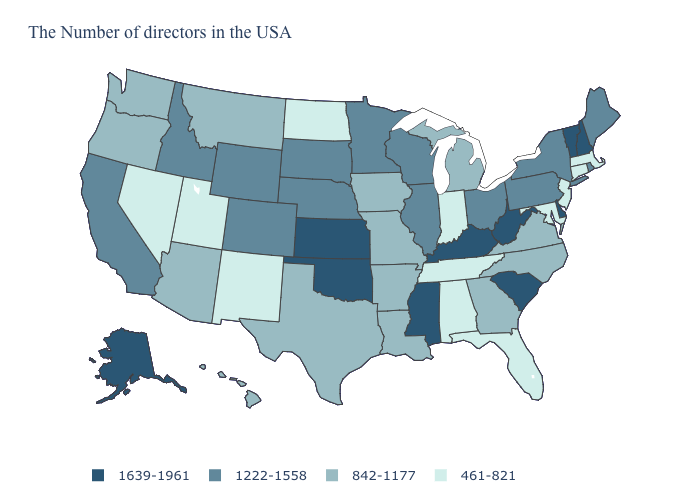Does Vermont have the same value as Nebraska?
Concise answer only. No. Name the states that have a value in the range 842-1177?
Concise answer only. Virginia, North Carolina, Georgia, Michigan, Louisiana, Missouri, Arkansas, Iowa, Texas, Montana, Arizona, Washington, Oregon, Hawaii. Does the map have missing data?
Be succinct. No. Name the states that have a value in the range 842-1177?
Give a very brief answer. Virginia, North Carolina, Georgia, Michigan, Louisiana, Missouri, Arkansas, Iowa, Texas, Montana, Arizona, Washington, Oregon, Hawaii. Is the legend a continuous bar?
Be succinct. No. Does Tennessee have a lower value than South Carolina?
Short answer required. Yes. Does the map have missing data?
Give a very brief answer. No. Name the states that have a value in the range 842-1177?
Give a very brief answer. Virginia, North Carolina, Georgia, Michigan, Louisiana, Missouri, Arkansas, Iowa, Texas, Montana, Arizona, Washington, Oregon, Hawaii. Does the map have missing data?
Concise answer only. No. Among the states that border Arkansas , which have the highest value?
Concise answer only. Mississippi, Oklahoma. What is the value of Minnesota?
Be succinct. 1222-1558. How many symbols are there in the legend?
Write a very short answer. 4. Name the states that have a value in the range 842-1177?
Concise answer only. Virginia, North Carolina, Georgia, Michigan, Louisiana, Missouri, Arkansas, Iowa, Texas, Montana, Arizona, Washington, Oregon, Hawaii. Does the first symbol in the legend represent the smallest category?
Keep it brief. No. Which states hav the highest value in the South?
Write a very short answer. Delaware, South Carolina, West Virginia, Kentucky, Mississippi, Oklahoma. 